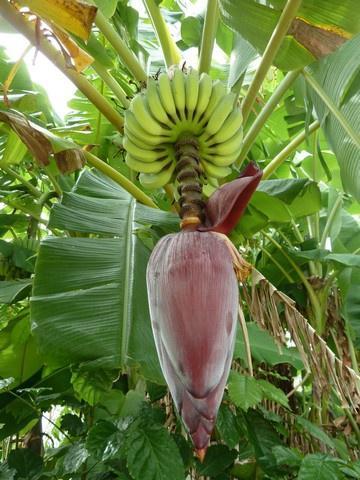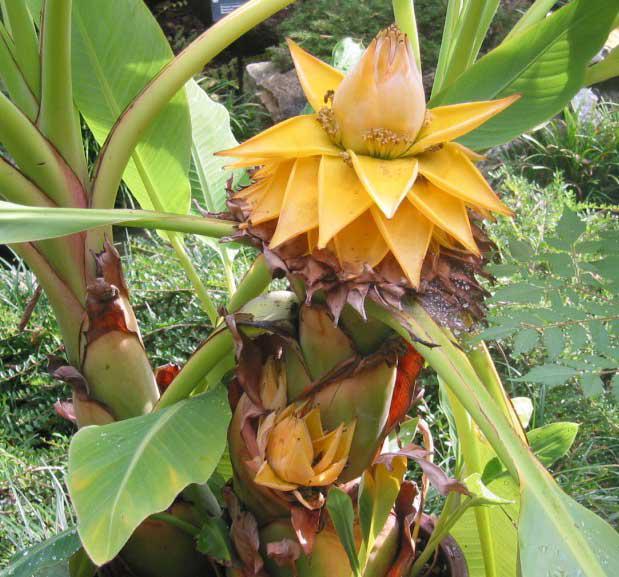The first image is the image on the left, the second image is the image on the right. Examine the images to the left and right. Is the description "Each image shows a large purplish flower beneath bunches of green bananas, but no image shows a flower with more than three petals fanning out." accurate? Answer yes or no. No. 